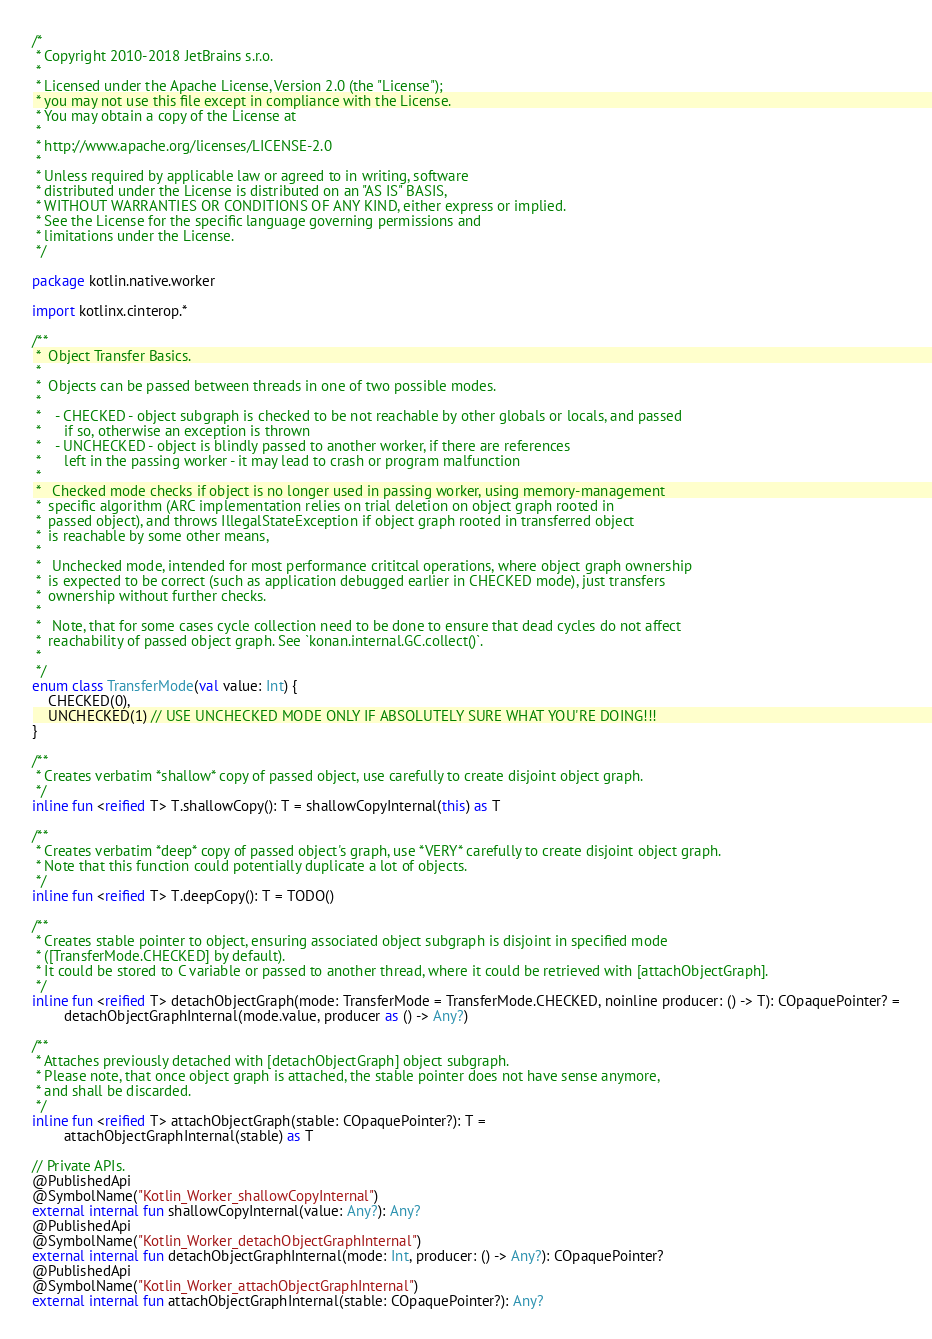<code> <loc_0><loc_0><loc_500><loc_500><_Kotlin_>/*
 * Copyright 2010-2018 JetBrains s.r.o.
 *
 * Licensed under the Apache License, Version 2.0 (the "License");
 * you may not use this file except in compliance with the License.
 * You may obtain a copy of the License at
 *
 * http://www.apache.org/licenses/LICENSE-2.0
 *
 * Unless required by applicable law or agreed to in writing, software
 * distributed under the License is distributed on an "AS IS" BASIS,
 * WITHOUT WARRANTIES OR CONDITIONS OF ANY KIND, either express or implied.
 * See the License for the specific language governing permissions and
 * limitations under the License.
 */

package kotlin.native.worker

import kotlinx.cinterop.*

/**
 *  Object Transfer Basics.
 *
 *  Objects can be passed between threads in one of two possible modes.
 *
 *    - CHECKED - object subgraph is checked to be not reachable by other globals or locals, and passed
 *      if so, otherwise an exception is thrown
 *    - UNCHECKED - object is blindly passed to another worker, if there are references
 *      left in the passing worker - it may lead to crash or program malfunction
 *
 *   Checked mode checks if object is no longer used in passing worker, using memory-management
 *  specific algorithm (ARC implementation relies on trial deletion on object graph rooted in
 *  passed object), and throws IllegalStateException if object graph rooted in transferred object
 *  is reachable by some other means,
 *
 *   Unchecked mode, intended for most performance crititcal operations, where object graph ownership
 *  is expected to be correct (such as application debugged earlier in CHECKED mode), just transfers
 *  ownership without further checks.
 *
 *   Note, that for some cases cycle collection need to be done to ensure that dead cycles do not affect
 *  reachability of passed object graph. See `konan.internal.GC.collect()`.
 *
 */
enum class TransferMode(val value: Int) {
    CHECKED(0),
    UNCHECKED(1) // USE UNCHECKED MODE ONLY IF ABSOLUTELY SURE WHAT YOU'RE DOING!!!
}

/**
 * Creates verbatim *shallow* copy of passed object, use carefully to create disjoint object graph.
 */
inline fun <reified T> T.shallowCopy(): T = shallowCopyInternal(this) as T

/**
 * Creates verbatim *deep* copy of passed object's graph, use *VERY* carefully to create disjoint object graph.
 * Note that this function could potentially duplicate a lot of objects.
 */
inline fun <reified T> T.deepCopy(): T = TODO()

/**
 * Creates stable pointer to object, ensuring associated object subgraph is disjoint in specified mode
 * ([TransferMode.CHECKED] by default).
 * It could be stored to C variable or passed to another thread, where it could be retrieved with [attachObjectGraph].
 */
inline fun <reified T> detachObjectGraph(mode: TransferMode = TransferMode.CHECKED, noinline producer: () -> T): COpaquePointer? =
        detachObjectGraphInternal(mode.value, producer as () -> Any?)

/**
 * Attaches previously detached with [detachObjectGraph] object subgraph.
 * Please note, that once object graph is attached, the stable pointer does not have sense anymore,
 * and shall be discarded.
 */
inline fun <reified T> attachObjectGraph(stable: COpaquePointer?): T =
        attachObjectGraphInternal(stable) as T

// Private APIs.
@PublishedApi
@SymbolName("Kotlin_Worker_shallowCopyInternal")
external internal fun shallowCopyInternal(value: Any?): Any?
@PublishedApi
@SymbolName("Kotlin_Worker_detachObjectGraphInternal")
external internal fun detachObjectGraphInternal(mode: Int, producer: () -> Any?): COpaquePointer?
@PublishedApi
@SymbolName("Kotlin_Worker_attachObjectGraphInternal")
external internal fun attachObjectGraphInternal(stable: COpaquePointer?): Any?

</code> 